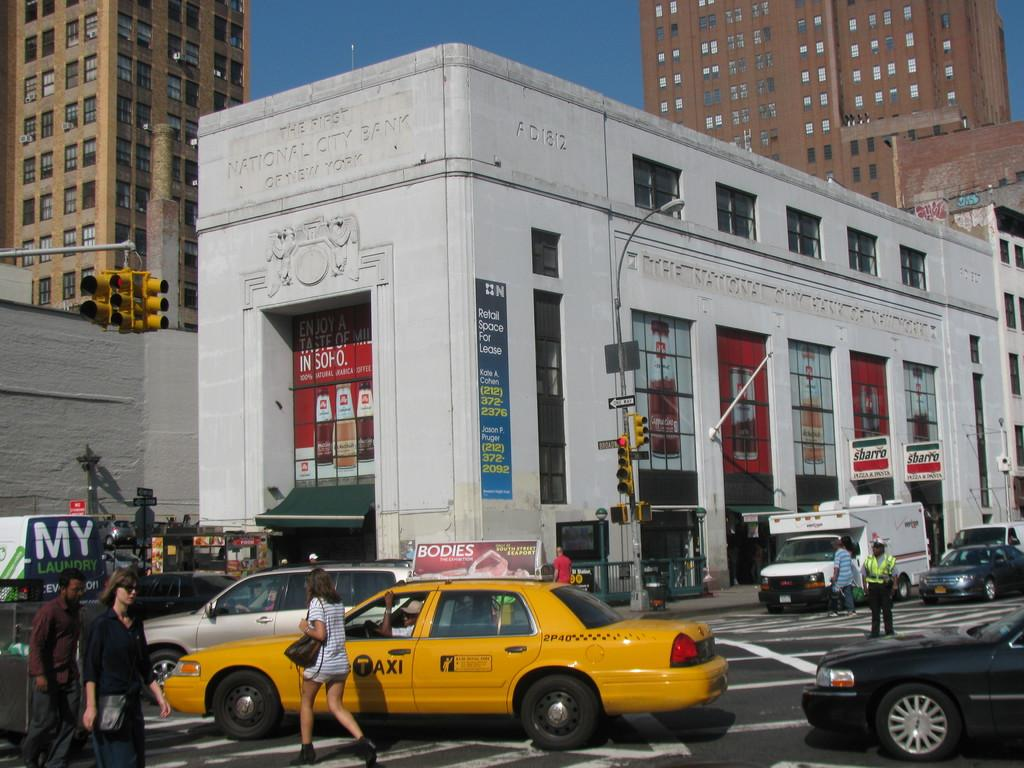<image>
Present a compact description of the photo's key features. People walk across a crosswalk in front of a yellow taxi in the city. 